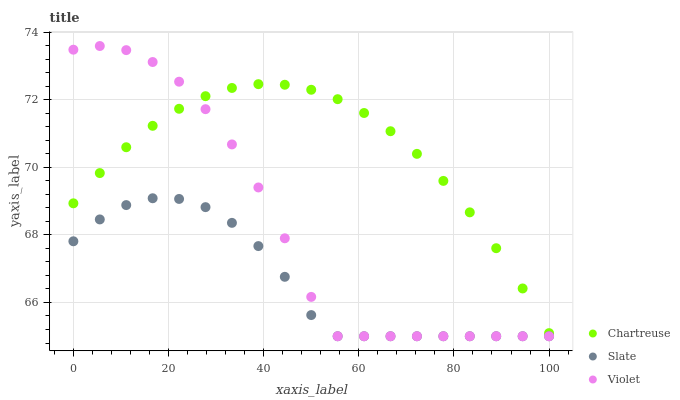Does Slate have the minimum area under the curve?
Answer yes or no. Yes. Does Chartreuse have the maximum area under the curve?
Answer yes or no. Yes. Does Violet have the minimum area under the curve?
Answer yes or no. No. Does Violet have the maximum area under the curve?
Answer yes or no. No. Is Chartreuse the smoothest?
Answer yes or no. Yes. Is Violet the roughest?
Answer yes or no. Yes. Is Slate the smoothest?
Answer yes or no. No. Is Slate the roughest?
Answer yes or no. No. Does Slate have the lowest value?
Answer yes or no. Yes. Does Violet have the highest value?
Answer yes or no. Yes. Does Slate have the highest value?
Answer yes or no. No. Is Slate less than Chartreuse?
Answer yes or no. Yes. Is Chartreuse greater than Slate?
Answer yes or no. Yes. Does Slate intersect Violet?
Answer yes or no. Yes. Is Slate less than Violet?
Answer yes or no. No. Is Slate greater than Violet?
Answer yes or no. No. Does Slate intersect Chartreuse?
Answer yes or no. No. 